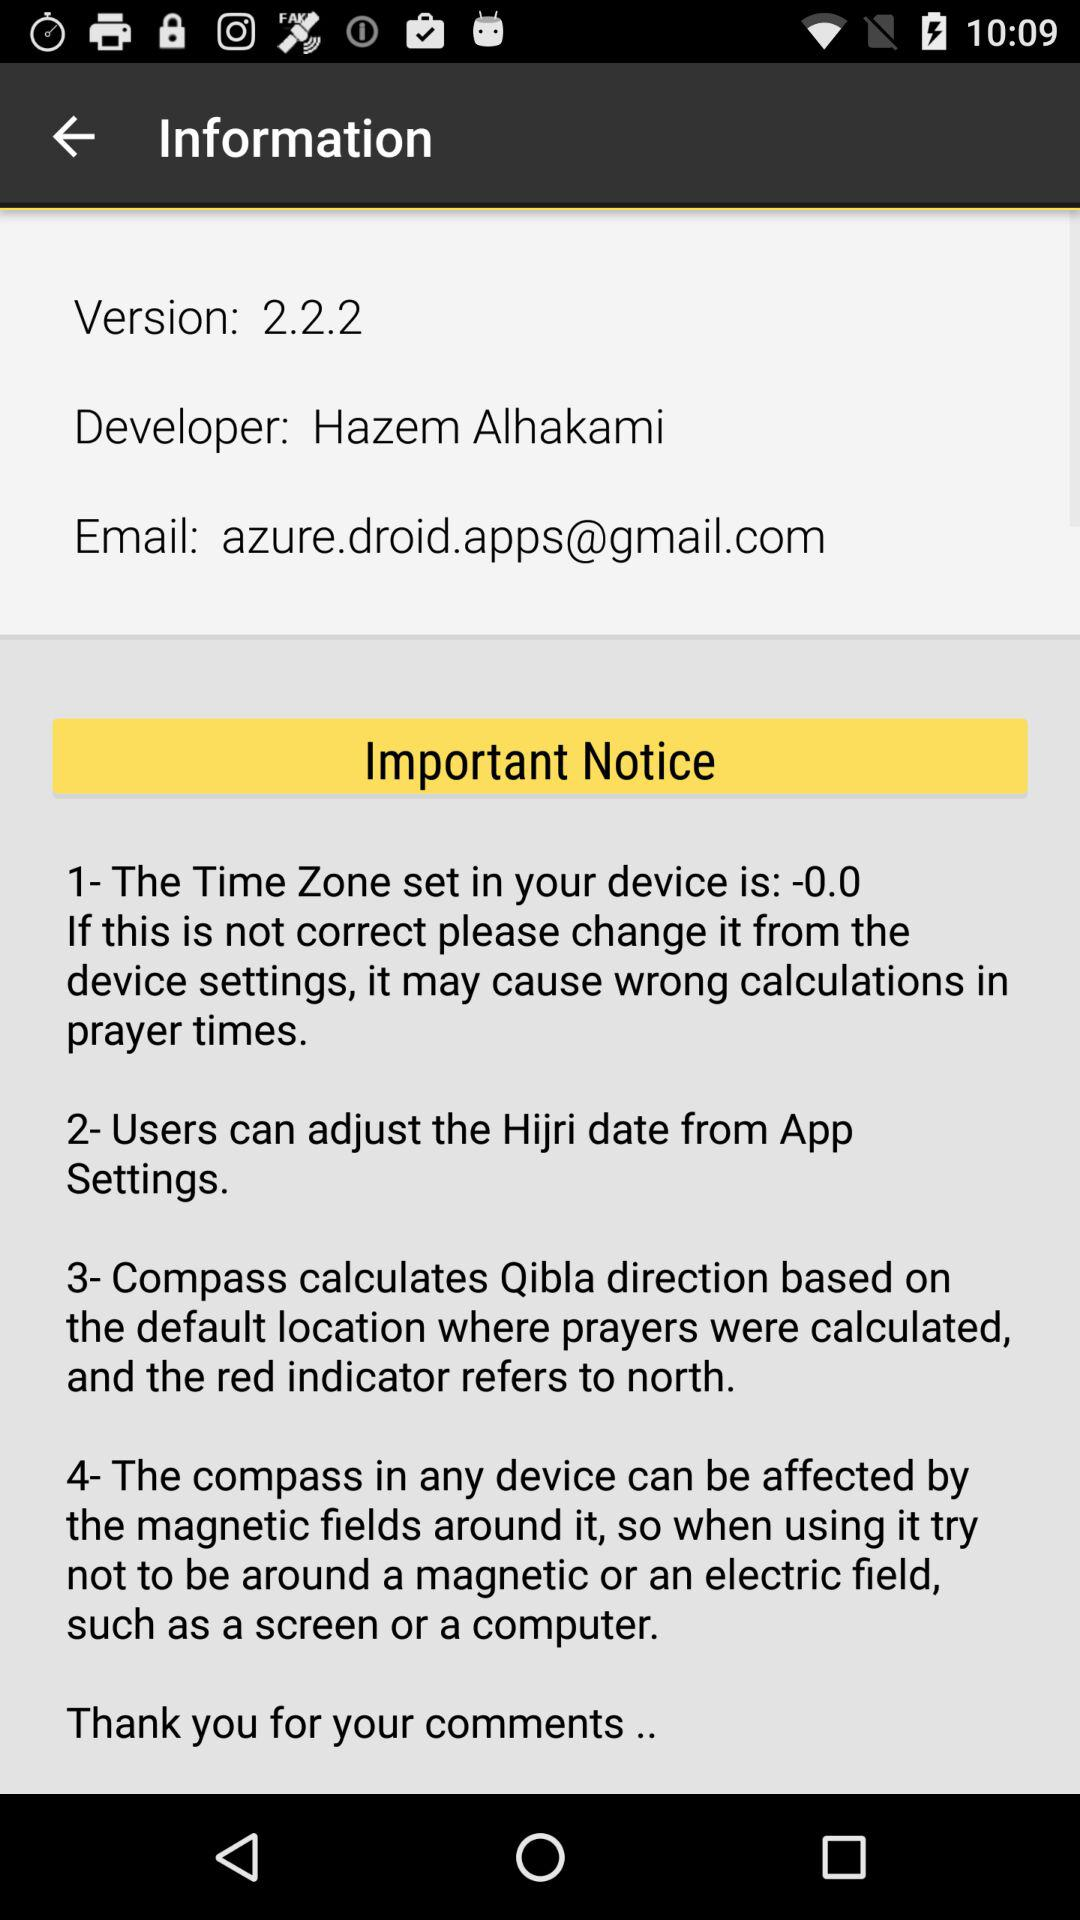How many lines of text are there in the information section?
Answer the question using a single word or phrase. 4 